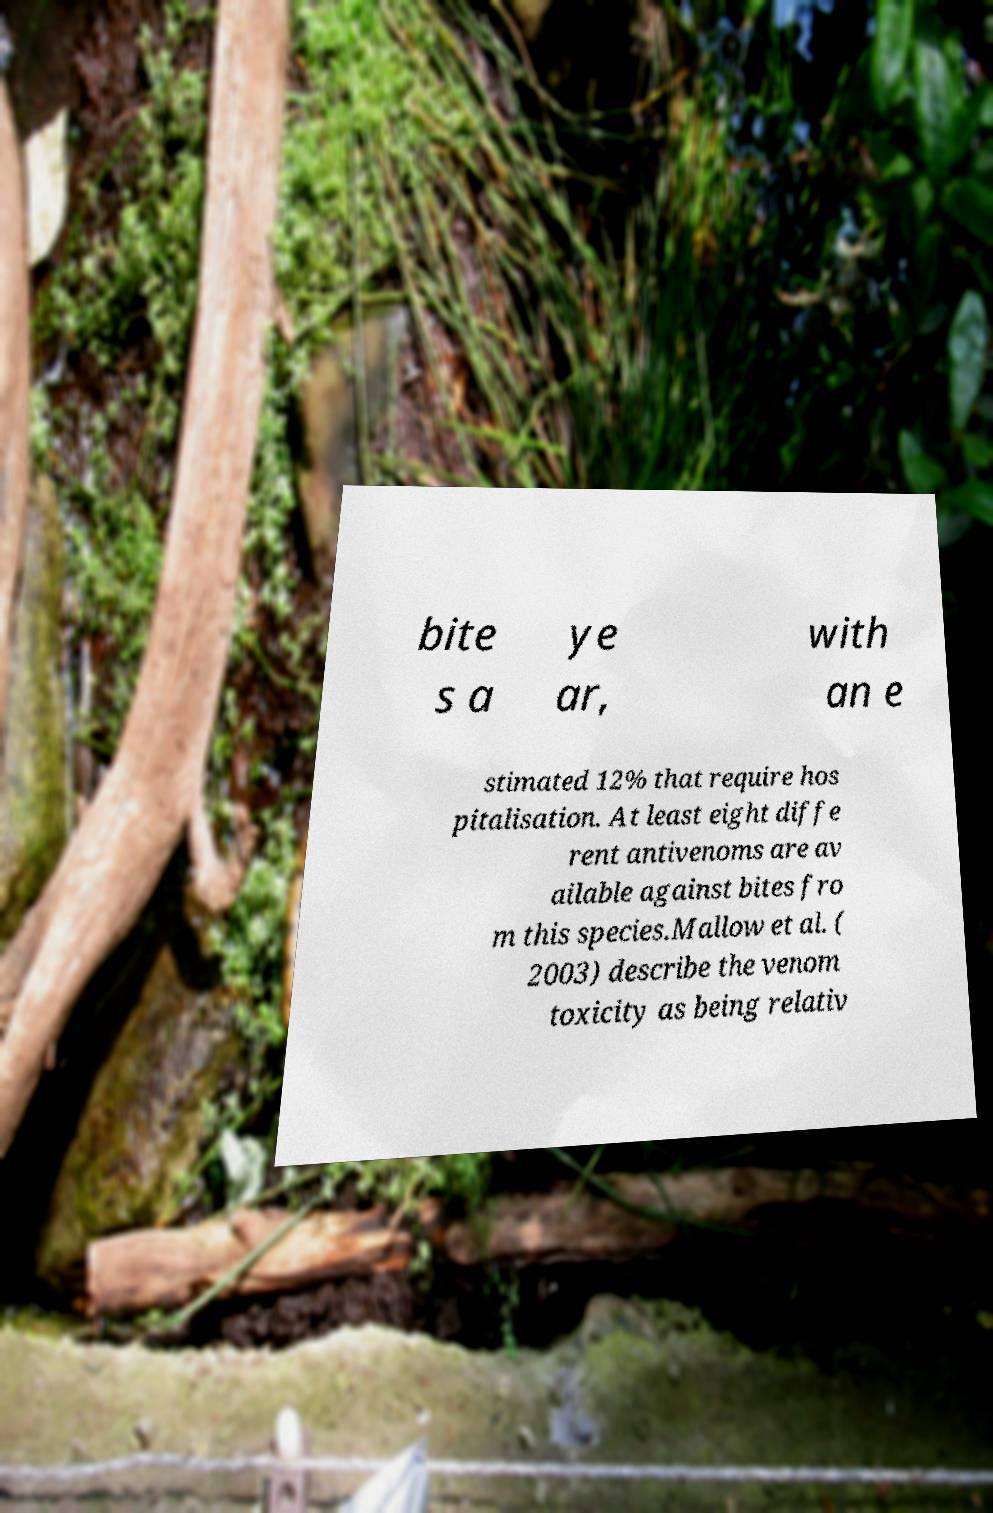Could you extract and type out the text from this image? bite s a ye ar, with an e stimated 12% that require hos pitalisation. At least eight diffe rent antivenoms are av ailable against bites fro m this species.Mallow et al. ( 2003) describe the venom toxicity as being relativ 